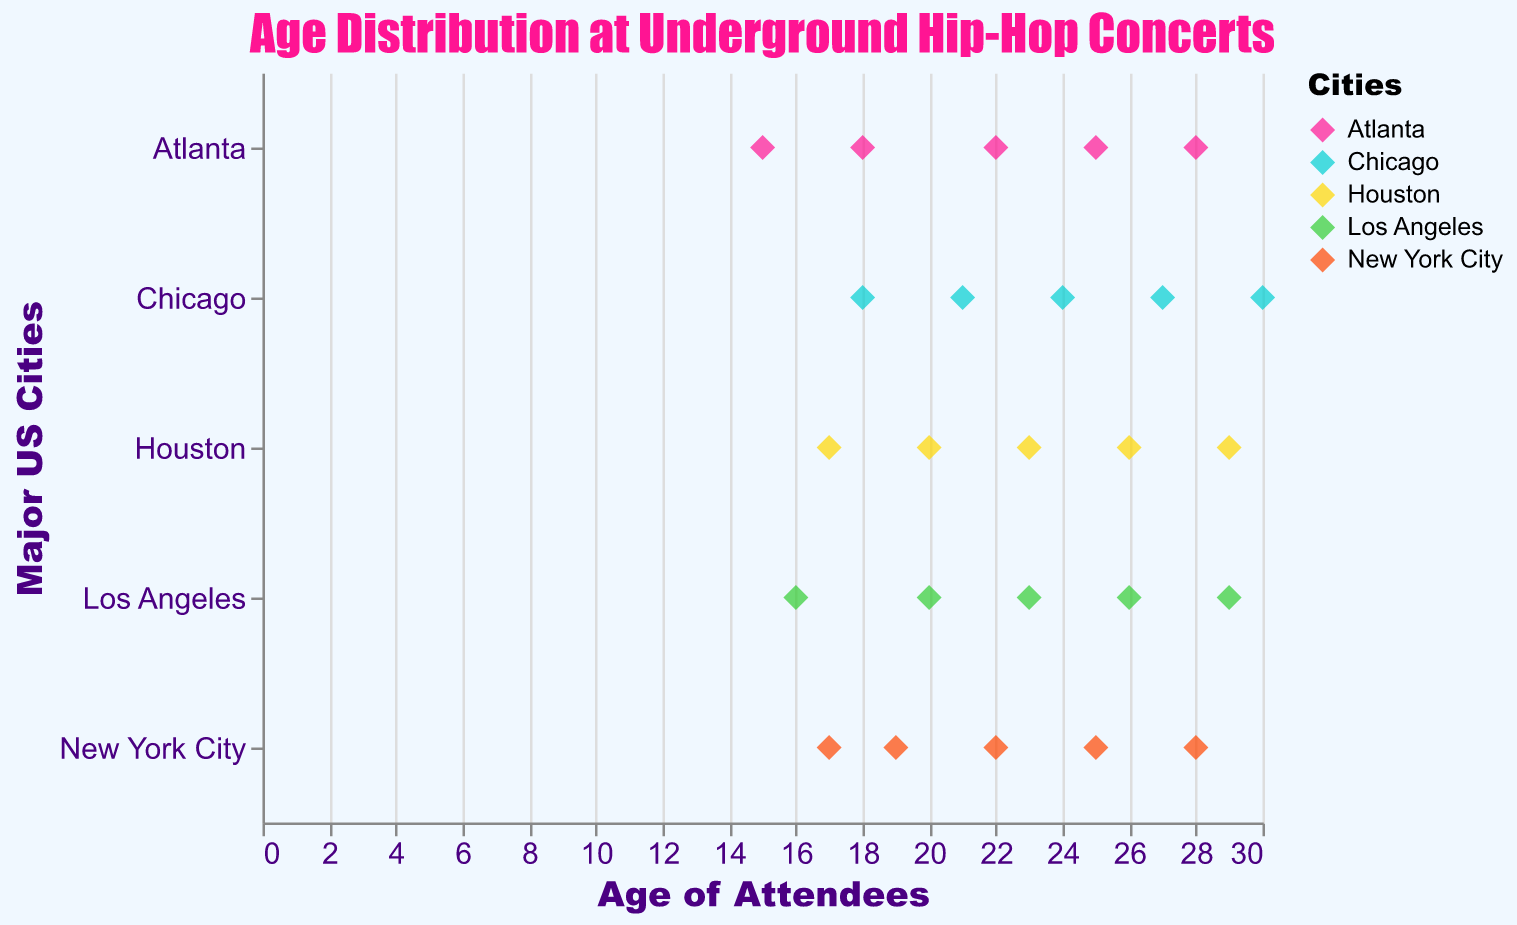What is the title of the plot? The title of the plot is displayed at the top in a prominent font style.
Answer: Age Distribution at Underground Hip-Hop Concerts Which city has the lowest age attendee and what is that age? Look at the lowest age value for each city. The lowest age value is for Atlanta.
Answer: Atlanta, 15 How many data points are there for Chicago? Count the number of data points corresponding to Chicago on the y-axis.
Answer: 5 What's the median age of attendees in Los Angeles? List the ages for Los Angeles: 16, 20, 23, 26, 29. The median is the middle value when ordered.
Answer: 23 Which city has the widest age range among attendees? Determine the range (max age - min age) for each city and compare. Chicago has the widest range.
Answer: Chicago What's the average age of attendees in Houston? Add the ages for Houston (17, 20, 23, 26, 29) and divide by the number of data points.
Answer: 23 Is there a city where the attendees' ages are evenly spaced? Check if the differences between consecutive age values are consistent. New York City and Chicago have evenly spaced ages.
Answer: Yes, New York City and Chicago Which city has the highest concentration of attendees between the ages 20-25? Count the data points within the 20-25 age range for each city. All cities have similar distribution, so none stands out significantly.
Answer: None stands out What age group has the highest concentration of attendees overall? Look for the age range with the most data points across all cities.
Answer: 20 to 25 